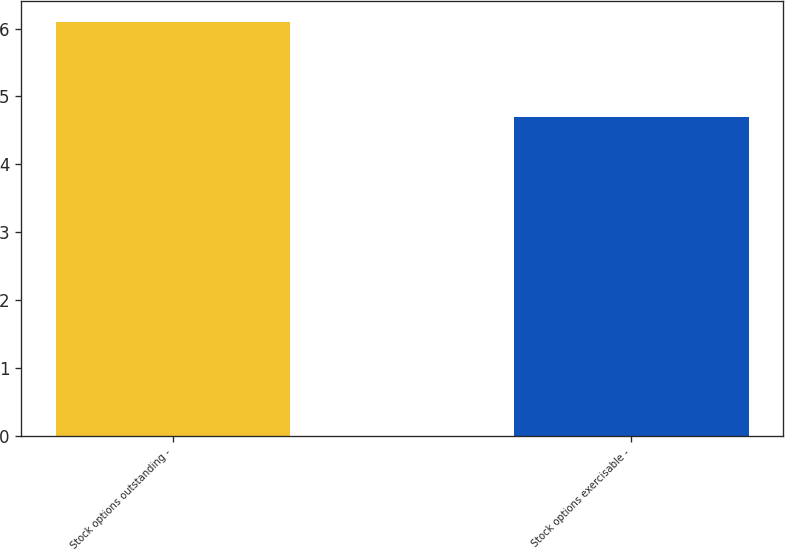Convert chart to OTSL. <chart><loc_0><loc_0><loc_500><loc_500><bar_chart><fcel>Stock options outstanding -<fcel>Stock options exercisable -<nl><fcel>6.1<fcel>4.7<nl></chart> 